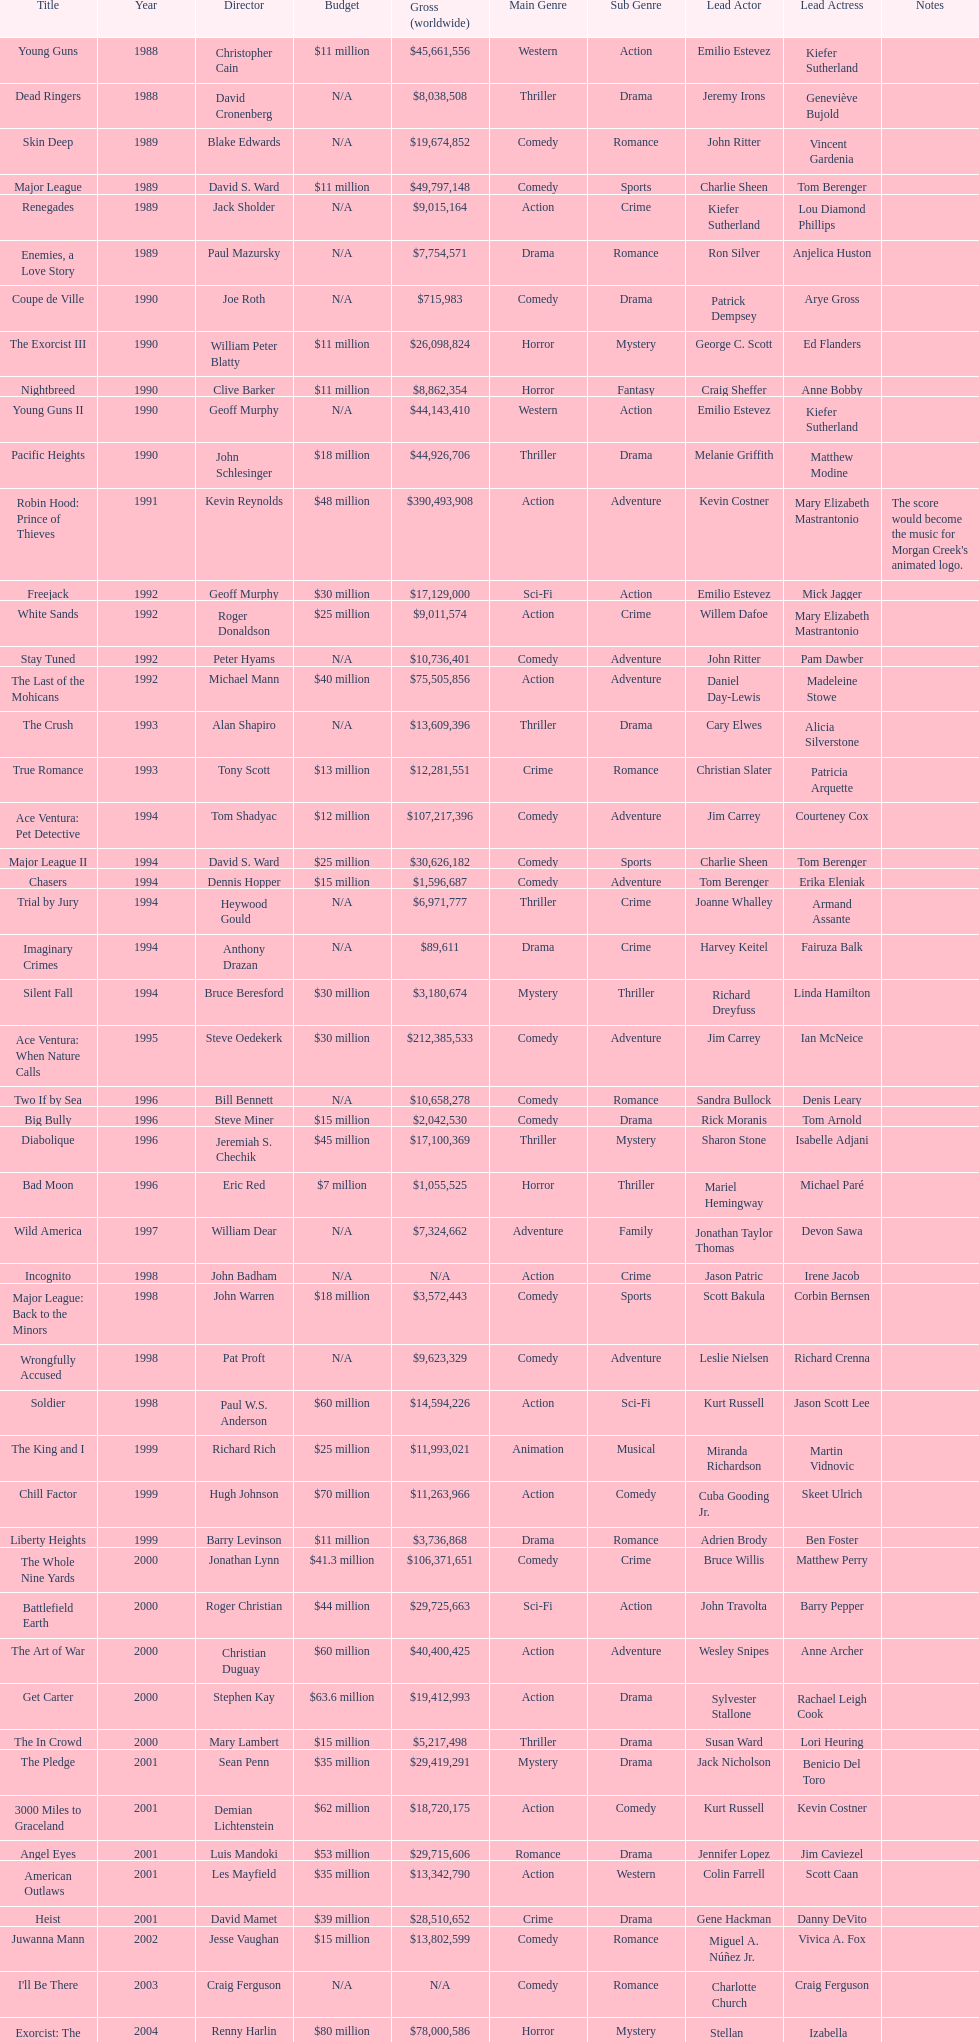Which morgan creek film grossed the most money prior to 1994? Robin Hood: Prince of Thieves. 